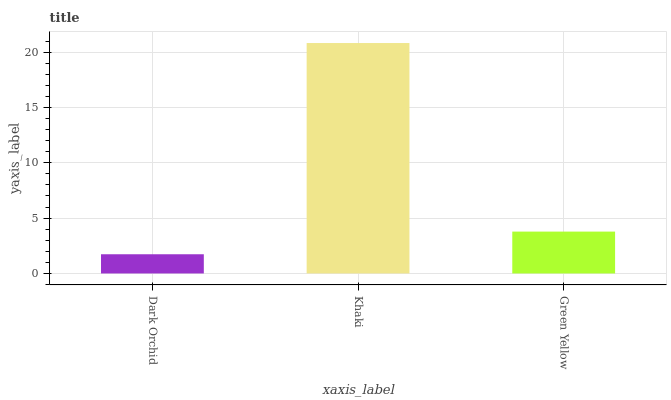Is Dark Orchid the minimum?
Answer yes or no. Yes. Is Khaki the maximum?
Answer yes or no. Yes. Is Green Yellow the minimum?
Answer yes or no. No. Is Green Yellow the maximum?
Answer yes or no. No. Is Khaki greater than Green Yellow?
Answer yes or no. Yes. Is Green Yellow less than Khaki?
Answer yes or no. Yes. Is Green Yellow greater than Khaki?
Answer yes or no. No. Is Khaki less than Green Yellow?
Answer yes or no. No. Is Green Yellow the high median?
Answer yes or no. Yes. Is Green Yellow the low median?
Answer yes or no. Yes. Is Dark Orchid the high median?
Answer yes or no. No. Is Khaki the low median?
Answer yes or no. No. 